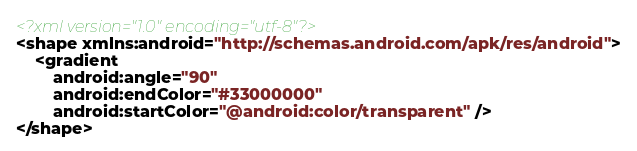Convert code to text. <code><loc_0><loc_0><loc_500><loc_500><_XML_><?xml version="1.0" encoding="utf-8"?>
<shape xmlns:android="http://schemas.android.com/apk/res/android">
    <gradient
        android:angle="90"
        android:endColor="#33000000"
        android:startColor="@android:color/transparent" />
</shape></code> 